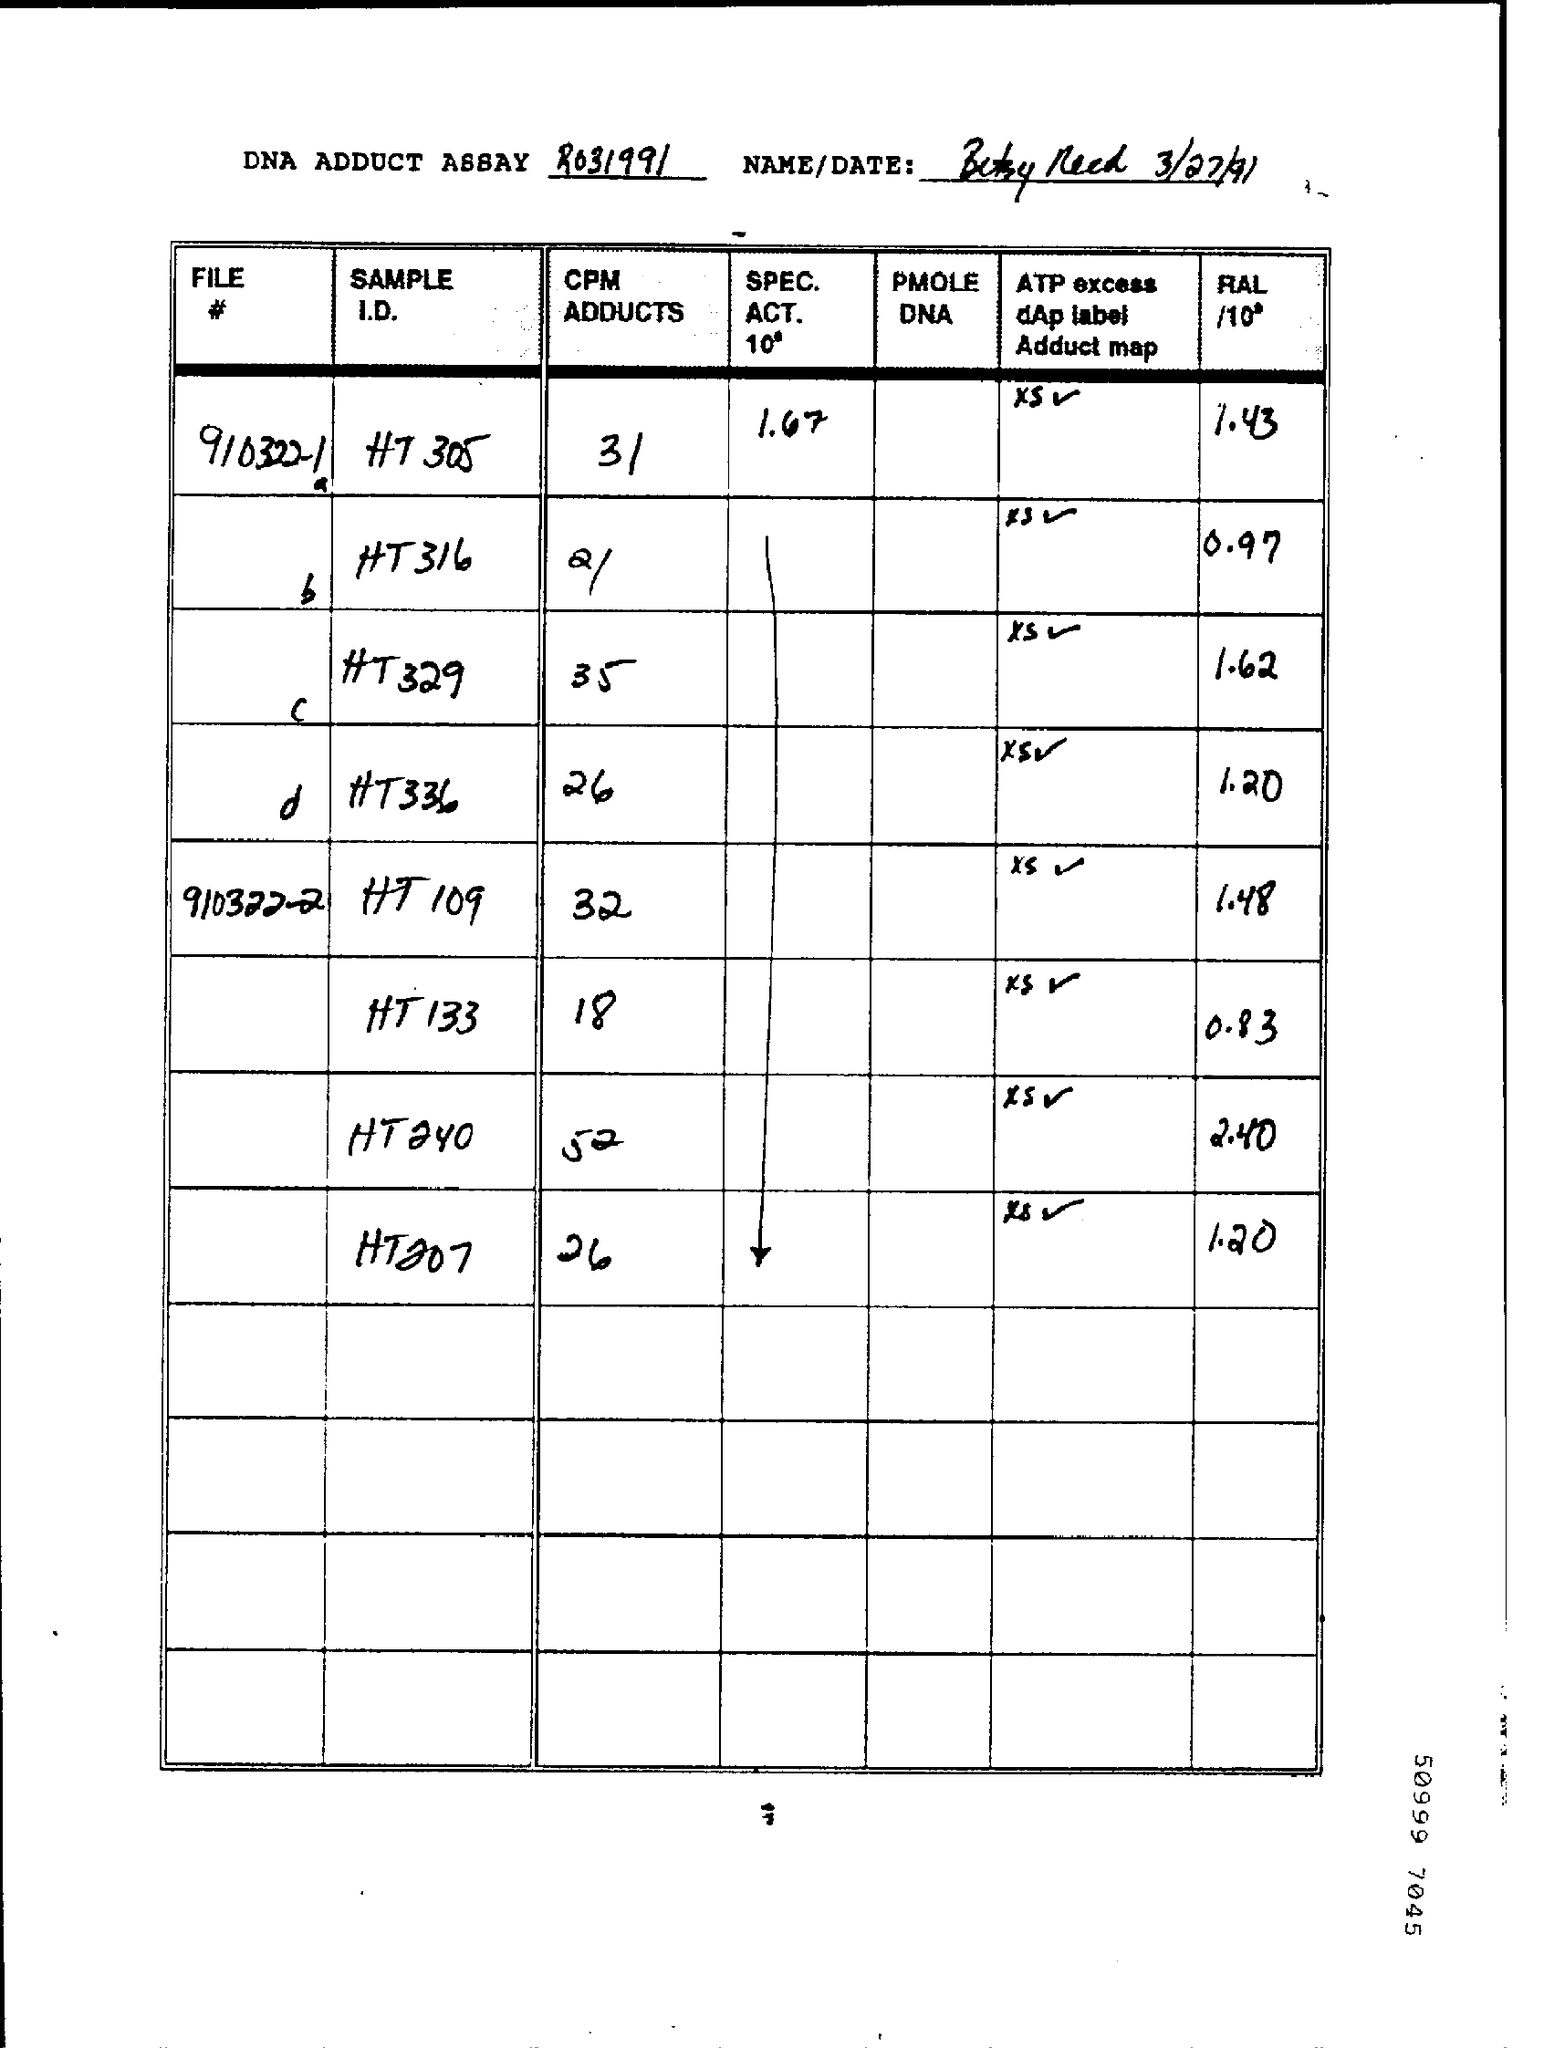What is the Date?
Ensure brevity in your answer.  3/27/91. What is the CPM ADDUCTS for File # 9103221a?
Make the answer very short. 31. What is the CPM ADDUCTS for File # 9103222?
Give a very brief answer. 32. 